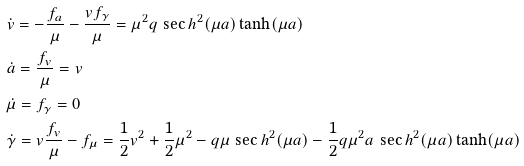<formula> <loc_0><loc_0><loc_500><loc_500>& \dot { v } = - \frac { f _ { a } } { \mu } - \frac { v f _ { \gamma } } { \mu } = \mu ^ { 2 } q \, \sec h ^ { 2 } ( \mu a ) \tanh ( \mu a ) \\ & \dot { a } = \frac { f _ { v } } { \mu } = v \\ & \dot { \mu } = f _ { \gamma } = 0 \\ & \dot { \gamma } = v \frac { f _ { v } } \mu - f _ { \mu } = \frac { 1 } { 2 } v ^ { 2 } + \frac { 1 } { 2 } \mu ^ { 2 } - q \mu \, \sec h ^ { 2 } ( \mu a ) - \frac { 1 } { 2 } q \mu ^ { 2 } a \, \sec h ^ { 2 } ( \mu a ) \tanh ( \mu a )</formula> 